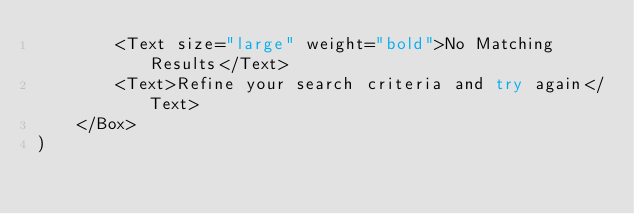<code> <loc_0><loc_0><loc_500><loc_500><_JavaScript_>        <Text size="large" weight="bold">No Matching Results</Text>
        <Text>Refine your search criteria and try again</Text>
    </Box>
)</code> 